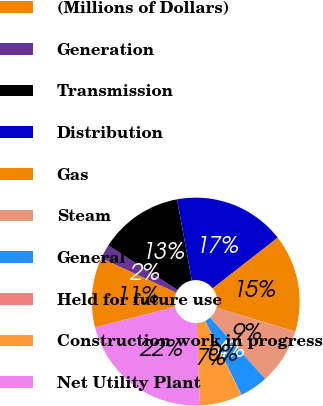Convert chart. <chart><loc_0><loc_0><loc_500><loc_500><pie_chart><fcel>(Millions of Dollars)<fcel>Generation<fcel>Transmission<fcel>Distribution<fcel>Gas<fcel>Steam<fcel>General<fcel>Held for future use<fcel>Construction work in progress<fcel>Net Utility Plant<nl><fcel>10.86%<fcel>2.22%<fcel>13.03%<fcel>17.35%<fcel>15.19%<fcel>8.7%<fcel>4.38%<fcel>0.06%<fcel>6.54%<fcel>21.67%<nl></chart> 